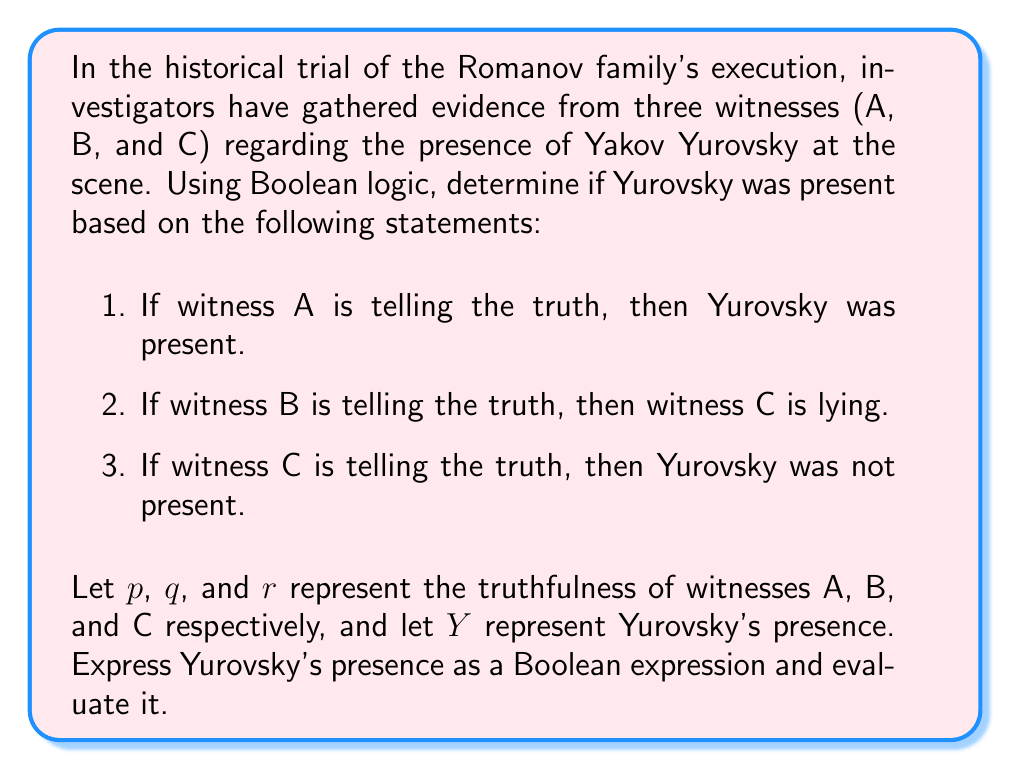Give your solution to this math problem. Let's approach this step-by-step using Boolean algebra:

1. Translate the given statements into Boolean expressions:
   a. $p \implies Y$
   b. $q \implies \neg r$
   c. $r \implies \neg Y$

2. We want to determine Y, so let's focus on expressions involving Y:
   From (a): $Y = p \lor \neg p \land Y$
   From (c): $Y = \neg r \lor r \land \neg Y$

3. Combine these expressions:
   $Y = (p \lor \neg p \land Y) \land (\neg r \lor r \land \neg Y)$

4. Simplify:
   $Y = (p \lor Y) \land (\neg r \lor \neg Y)$
   $Y = (p \land \neg r) \lor (p \land \neg Y) \lor (Y \land \neg r) \lor (Y \land \neg Y)$

5. $Y \land \neg Y = 0$, and $Y \lor (p \land \neg Y) = Y \lor p$, so:
   $Y = (p \land \neg r) \lor (Y \land \neg r) \lor p$
   $Y = p \lor (Y \land \neg r)$

6. This is a recursive definition. To resolve it, we can substitute Y on the right side with the entire expression:
   $Y = p \lor ((p \lor (Y \land \neg r)) \land \neg r)$

7. Simplify:
   $Y = p \lor (p \land \neg r) \lor (Y \land \neg r \land \neg r)$
   $Y = p \lor (p \land \neg r) \lor (Y \land \neg r)$
   $Y = p \lor (Y \land \neg r)$

We've arrived at the same expression as in step 5, which means this is the simplest form.

8. Interpret the result:
   Yurovsky was present (Y is true) if either:
   - Witness A is telling the truth (p is true), or
   - Yurovsky was present and witness C is lying (Y is true and r is false)

This means that Yurovsky's presence depends only on the testimonies of witnesses A and C, and is independent of witness B's testimony.
Answer: $Y = p \lor (Y \land \neg r)$ 